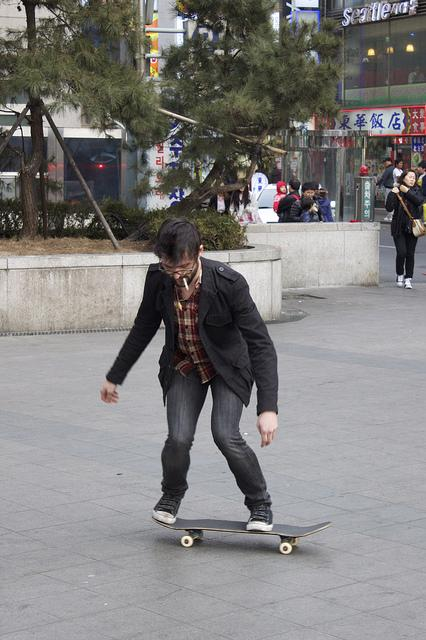What part of his body will be most harmed by the item in his mouth?

Choices:
A) back
B) lungs
C) feet
D) eyes lungs 